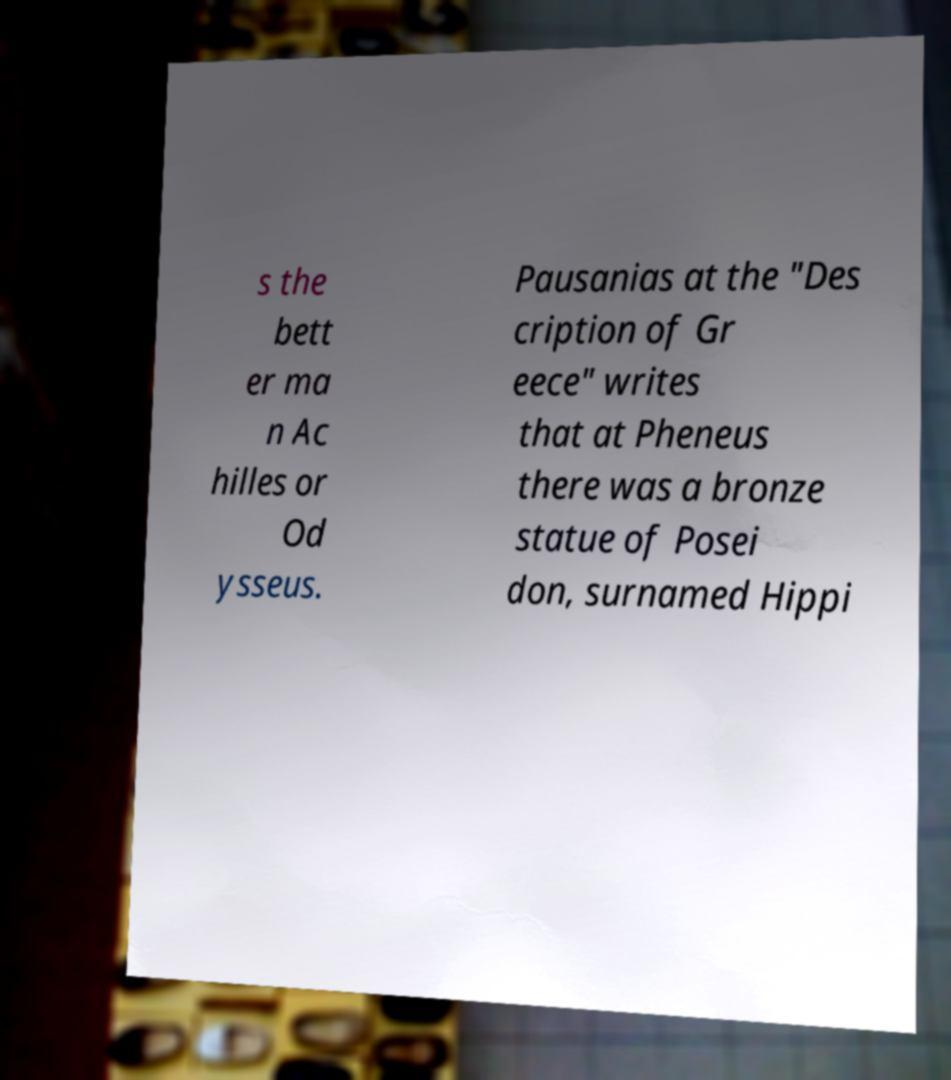I need the written content from this picture converted into text. Can you do that? s the bett er ma n Ac hilles or Od ysseus. Pausanias at the "Des cription of Gr eece" writes that at Pheneus there was a bronze statue of Posei don, surnamed Hippi 